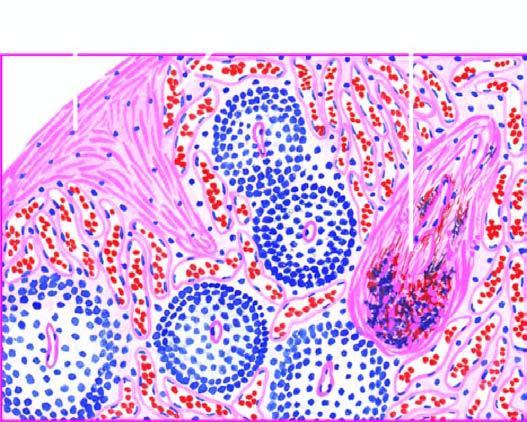s there increased fibrosis in the red pulp, capsule and the trabeculae?
Answer the question using a single word or phrase. Yes 